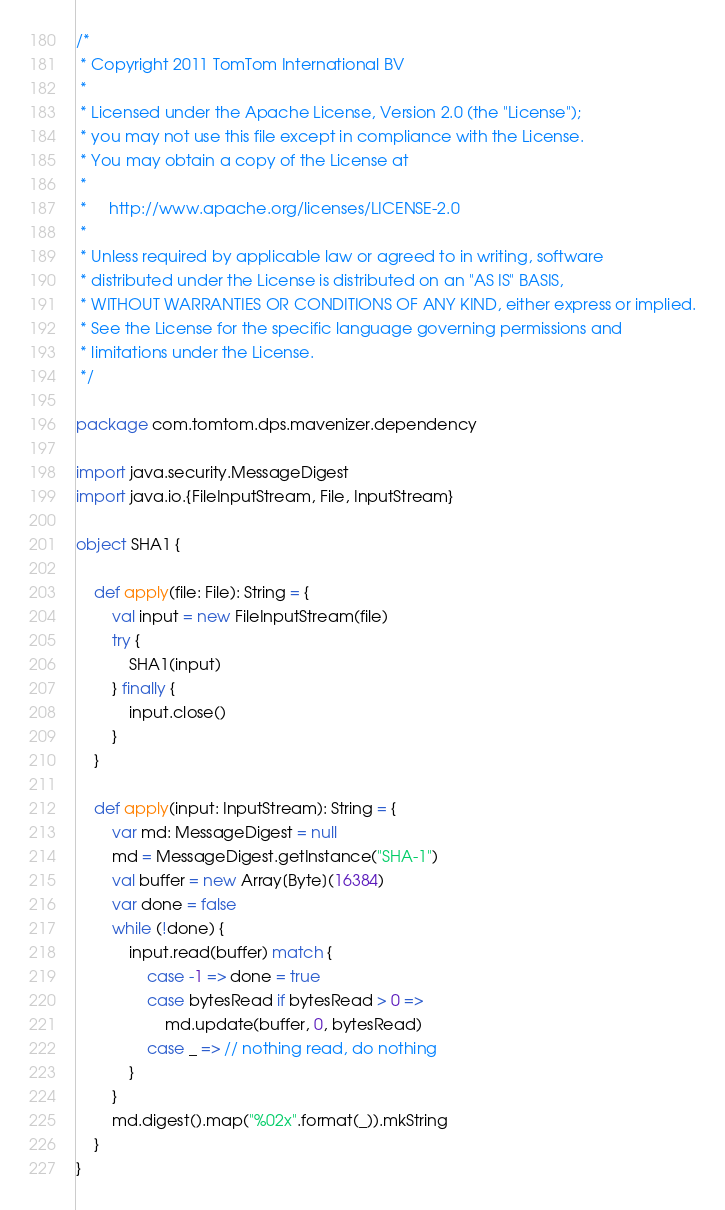Convert code to text. <code><loc_0><loc_0><loc_500><loc_500><_Scala_>/*
 * Copyright 2011 TomTom International BV
 *
 * Licensed under the Apache License, Version 2.0 (the "License");
 * you may not use this file except in compliance with the License.
 * You may obtain a copy of the License at
 *
 *     http://www.apache.org/licenses/LICENSE-2.0
 *
 * Unless required by applicable law or agreed to in writing, software
 * distributed under the License is distributed on an "AS IS" BASIS,
 * WITHOUT WARRANTIES OR CONDITIONS OF ANY KIND, either express or implied.
 * See the License for the specific language governing permissions and
 * limitations under the License.
 */

package com.tomtom.dps.mavenizer.dependency

import java.security.MessageDigest
import java.io.{FileInputStream, File, InputStream}

object SHA1 {

    def apply(file: File): String = {
        val input = new FileInputStream(file)
        try {
            SHA1(input)
        } finally {
            input.close()
        }
    }

    def apply(input: InputStream): String = {
        var md: MessageDigest = null
        md = MessageDigest.getInstance("SHA-1")
        val buffer = new Array[Byte](16384)
        var done = false
        while (!done) {
            input.read(buffer) match {
                case -1 => done = true
                case bytesRead if bytesRead > 0 =>
                    md.update(buffer, 0, bytesRead)
                case _ => // nothing read, do nothing
            }
        }
        md.digest().map("%02x".format(_)).mkString
    }
}


</code> 